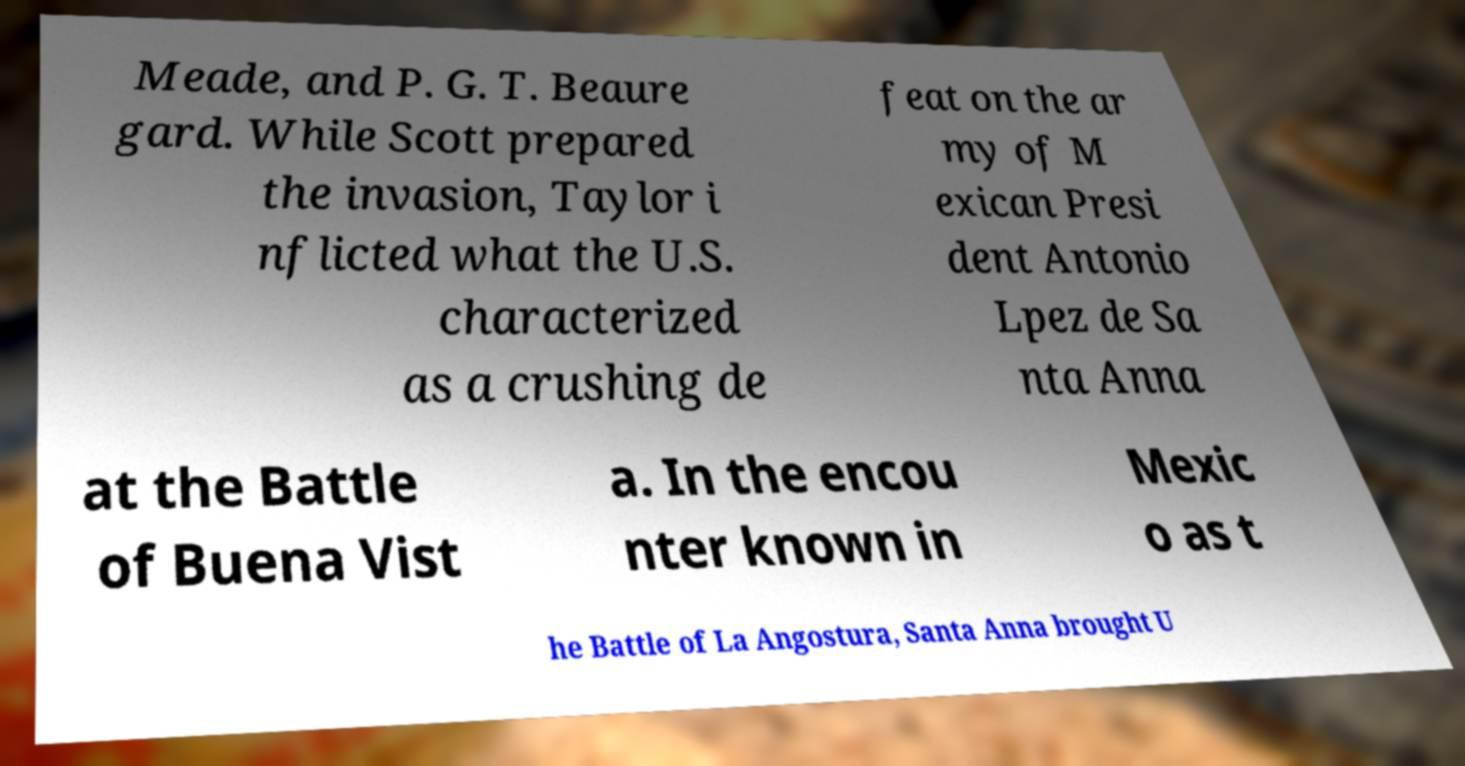There's text embedded in this image that I need extracted. Can you transcribe it verbatim? Meade, and P. G. T. Beaure gard. While Scott prepared the invasion, Taylor i nflicted what the U.S. characterized as a crushing de feat on the ar my of M exican Presi dent Antonio Lpez de Sa nta Anna at the Battle of Buena Vist a. In the encou nter known in Mexic o as t he Battle of La Angostura, Santa Anna brought U 